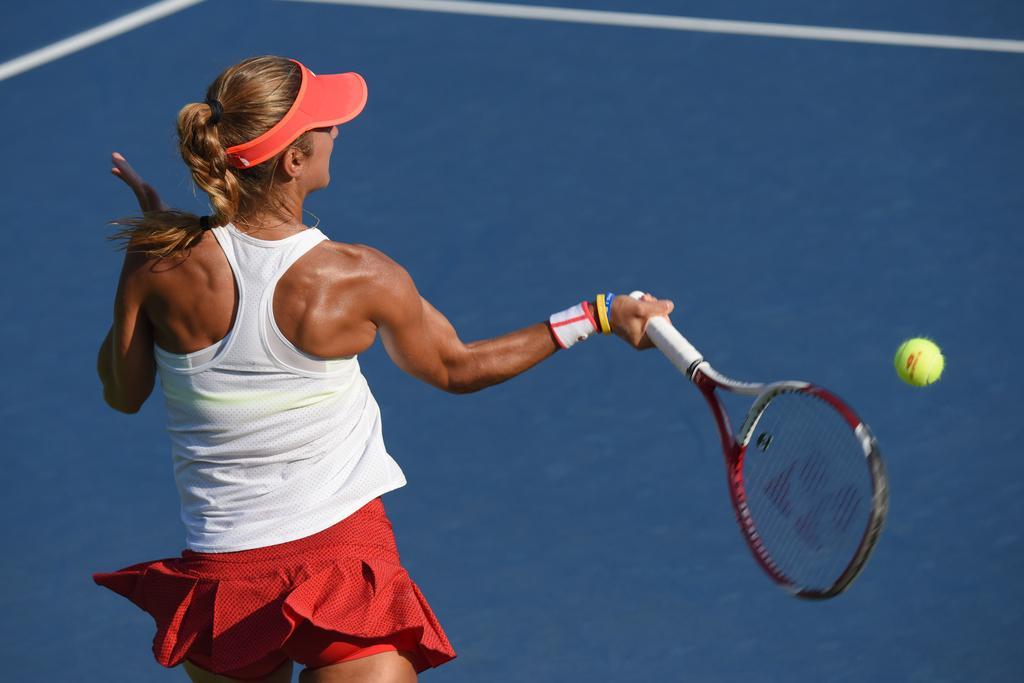In one or two sentences, can you explain what this image depicts? In this image I can see the person wearing the white and red color dress and also the red color cap. She is holding the racket. I can see the yellow color ball in the air. The person is on the court. 